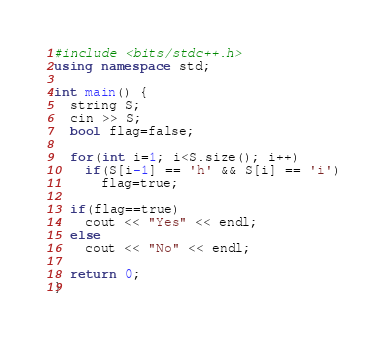<code> <loc_0><loc_0><loc_500><loc_500><_C++_>#include <bits/stdc++.h>
using namespace std;

int main() {
  string S;
  cin >> S;
  bool flag=false;
  
  for(int i=1; i<S.size(); i++)
    if(S[i-1] == 'h' && S[i] == 'i')
      flag=true;

  if(flag==true)
    cout << "Yes" << endl;
  else
    cout << "No" << endl;
  
  return 0;
}</code> 